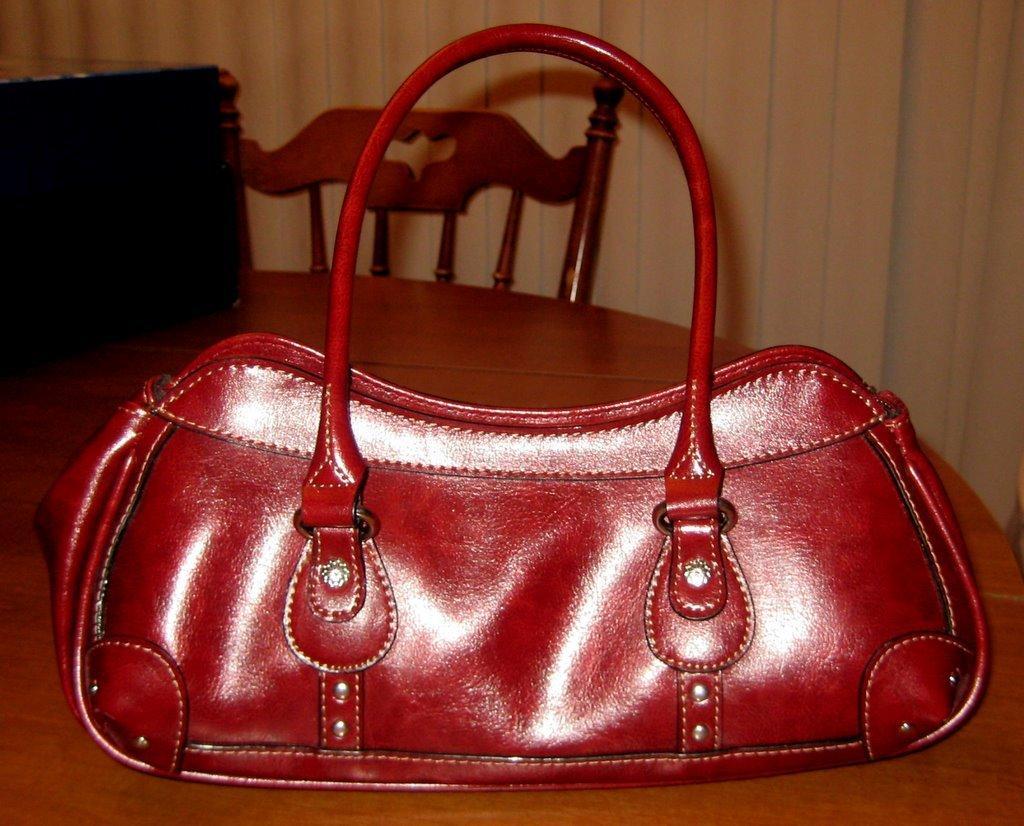Can you describe this image briefly? In this image I can see a bag on the table. 